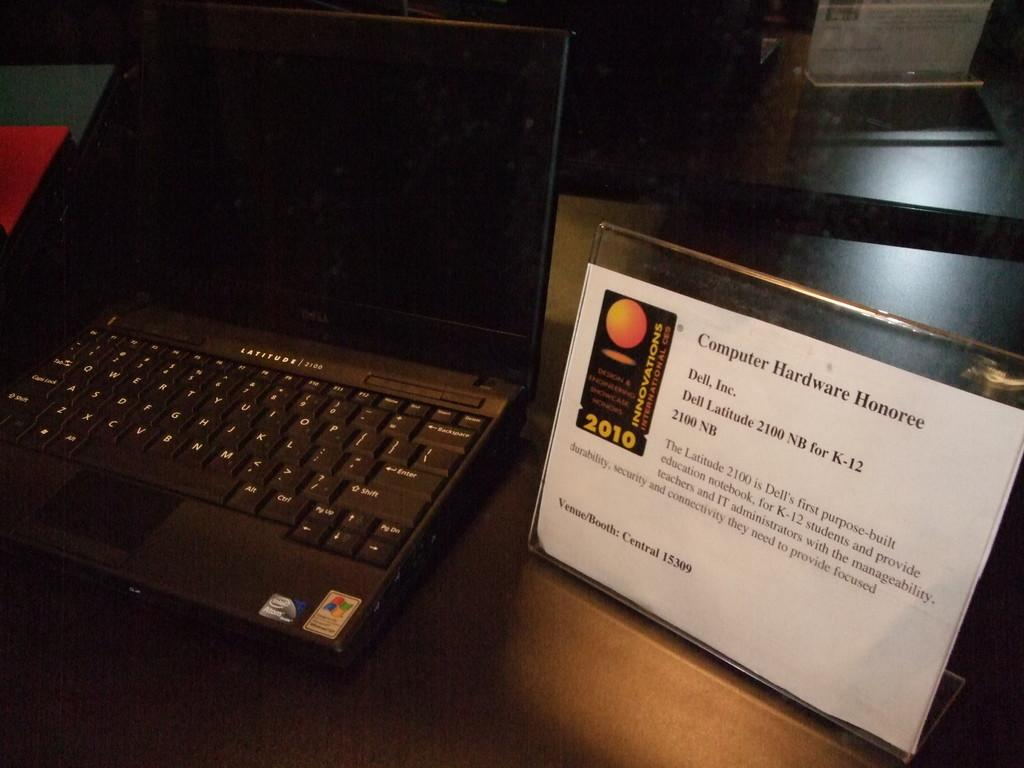<image>
Provide a brief description of the given image. a page next to a keyboard that is titled 'computer hardwater honoree' 